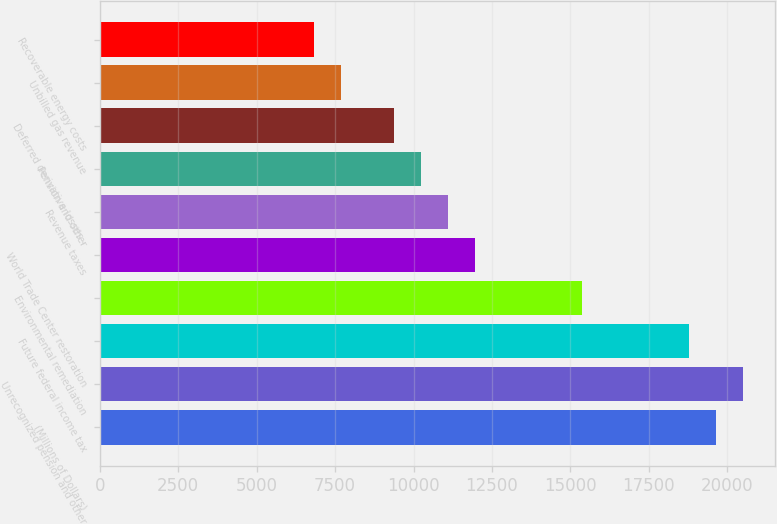Convert chart to OTSL. <chart><loc_0><loc_0><loc_500><loc_500><bar_chart><fcel>(Millions of Dollars)<fcel>Unrecognized pension and other<fcel>Future federal income tax<fcel>Environmental remediation<fcel>World Trade Center restoration<fcel>Revenue taxes<fcel>Pension and other<fcel>Deferred derivative losses -<fcel>Unbilled gas revenue<fcel>Recoverable energy costs<nl><fcel>19632.5<fcel>20486<fcel>18779<fcel>15365<fcel>11951<fcel>11097.5<fcel>10244<fcel>9390.5<fcel>7683.5<fcel>6830<nl></chart> 